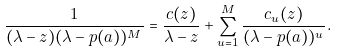Convert formula to latex. <formula><loc_0><loc_0><loc_500><loc_500>\frac { 1 } { ( \lambda - z ) ( \lambda - p ( a ) ) ^ { M } } = \frac { c ( z ) } { \lambda - z } + \sum _ { u = 1 } ^ { M } \frac { c _ { u } ( z ) } { ( \lambda - p ( a ) ) ^ { u } } .</formula> 